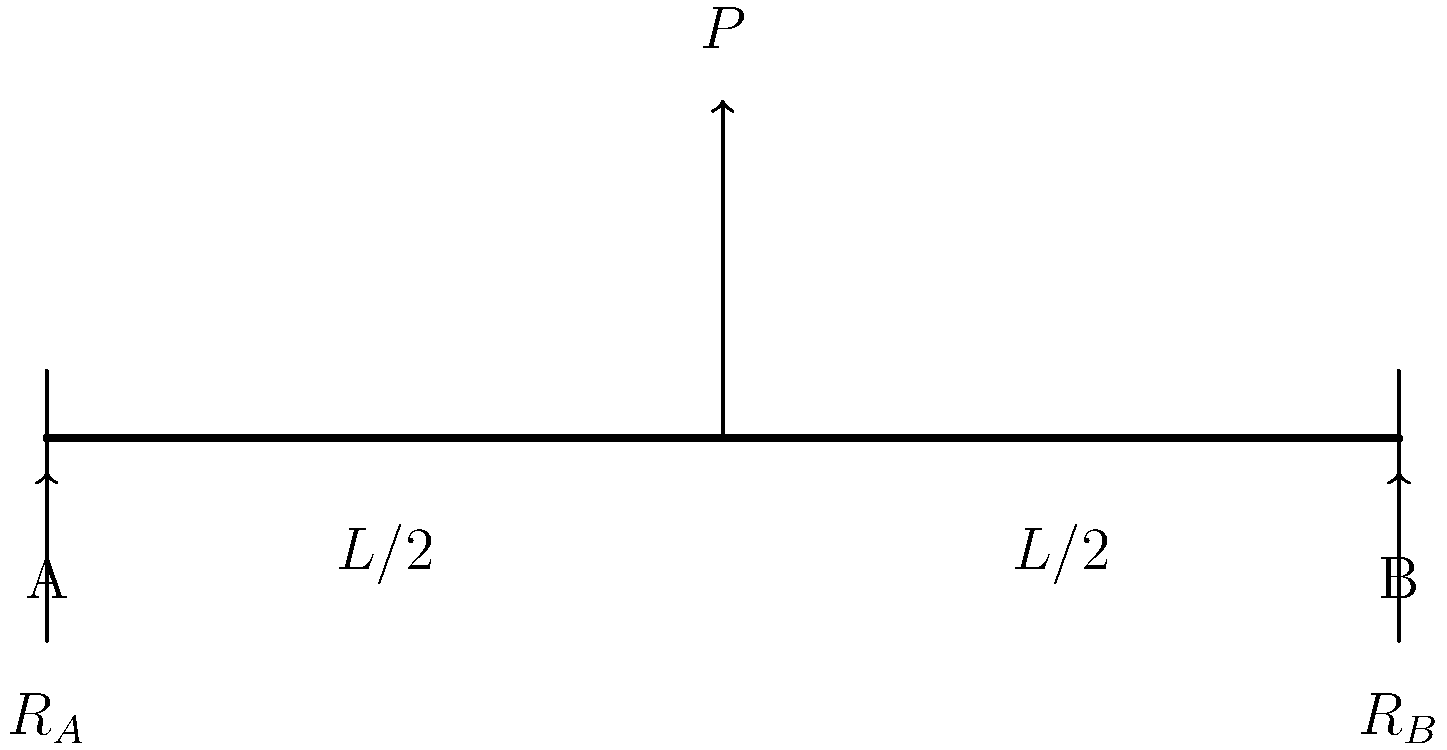A simply supported beam of length $L$ is subjected to a point load $P$ at its midpoint. Calculate the reaction forces $R_A$ and $R_B$ at the supports A and B, respectively. To solve this problem, we'll use the principles of statics and moment equilibrium:

1. Sum of forces in vertical direction must be zero:
   $$R_A + R_B - P = 0$$

2. Sum of moments about point A must be zero:
   $$R_B \cdot L - P \cdot \frac{L}{2} = 0$$

3. Solve for $R_B$ from the moment equation:
   $$R_B = \frac{P \cdot \frac{L}{2}}{L} = \frac{P}{2}$$

4. Substitute $R_B$ into the force equilibrium equation:
   $$R_A + \frac{P}{2} - P = 0$$
   $$R_A = P - \frac{P}{2} = \frac{P}{2}$$

5. Therefore, both reaction forces are equal:
   $$R_A = R_B = \frac{P}{2}$$

This result is logical due to the symmetry of the load placement.
Answer: $R_A = R_B = \frac{P}{2}$ 